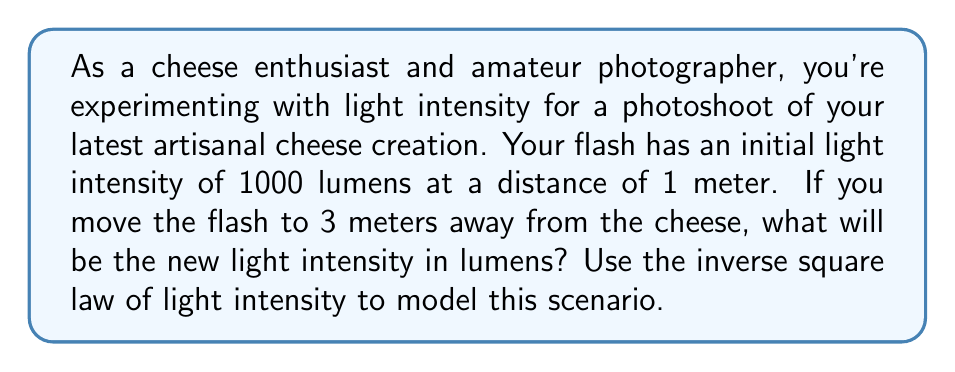Give your solution to this math problem. Let's approach this step-by-step using the inverse square law of light intensity:

1) The inverse square law states that light intensity is inversely proportional to the square of the distance from the source. We can express this as:

   $$I \propto \frac{1}{d^2}$$

   where $I$ is the light intensity and $d$ is the distance from the light source.

2) We can write this as an equation:

   $$I = \frac{k}{d^2}$$

   where $k$ is a constant that depends on the initial conditions.

3) We're given the initial conditions: at 1 meter, the intensity is 1000 lumens. Let's use this to find $k$:

   $$1000 = \frac{k}{1^2}$$
   $$k = 1000$$

4) Now we have our specific function:

   $$I = \frac{1000}{d^2}$$

5) To find the intensity at 3 meters, we simply plug in $d = 3$:

   $$I = \frac{1000}{3^2} = \frac{1000}{9} \approx 111.11$$

Therefore, at 3 meters, the light intensity will be approximately 111.11 lumens.
Answer: 111.11 lumens 